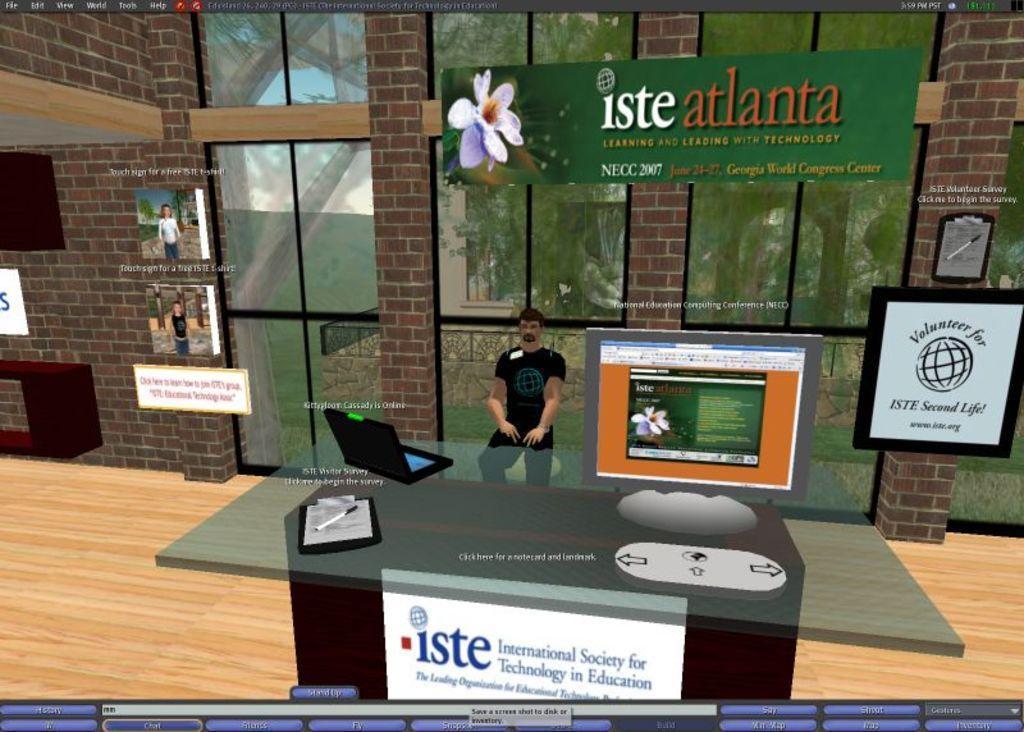Describe this image in one or two sentences. This is an animation in this image in the center there is one person standing, and there is a table. On the table there is a laptop, papers, pen and there is a computer. In the background there are glass windows and board, on the board there is text and also on the right side and left side there are some boards and posters and there is a wall and pen. At the bottom there is floor, and at the bottom of the image there is some text. 